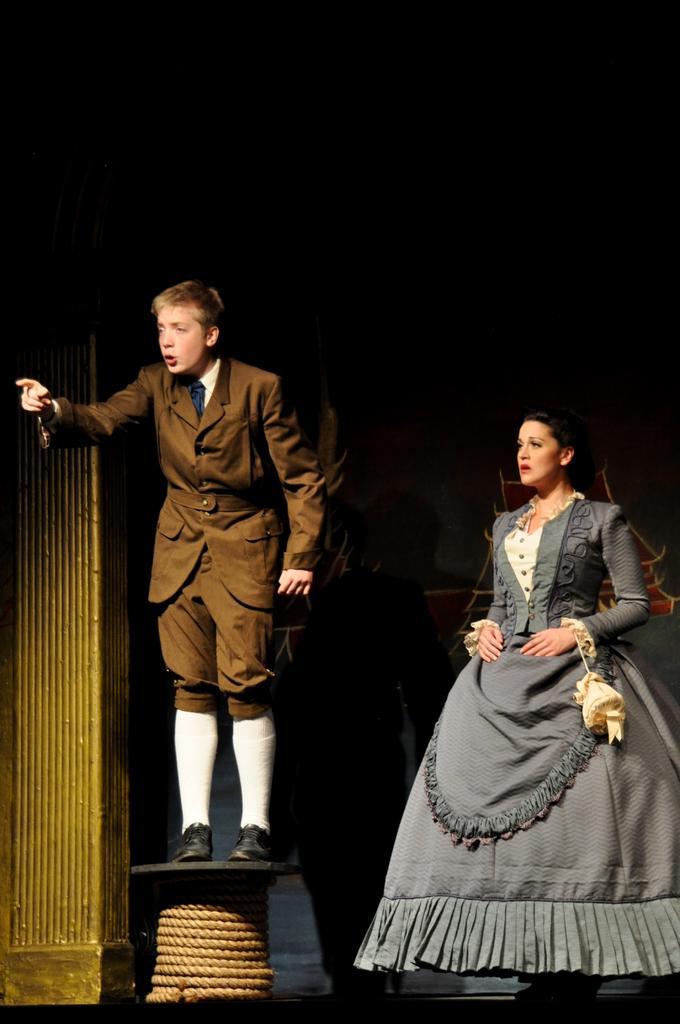Can you describe this image briefly? In this image I can see a woman and man. Man is standing on the table, to that table there is a rope. In the background of the image I can see objects and it is dark. Near that woman I can see a pouch. 